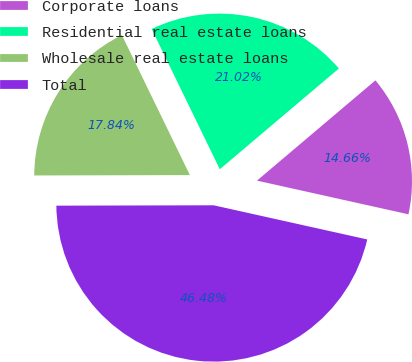Convert chart to OTSL. <chart><loc_0><loc_0><loc_500><loc_500><pie_chart><fcel>Corporate loans<fcel>Residential real estate loans<fcel>Wholesale real estate loans<fcel>Total<nl><fcel>14.66%<fcel>21.02%<fcel>17.84%<fcel>46.48%<nl></chart> 